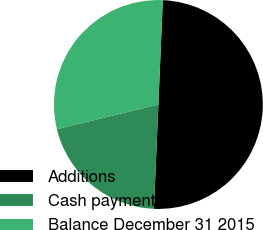Convert chart. <chart><loc_0><loc_0><loc_500><loc_500><pie_chart><fcel>Additions<fcel>Cash payments<fcel>Balance December 31 2015<nl><fcel>50.0%<fcel>20.53%<fcel>29.47%<nl></chart> 